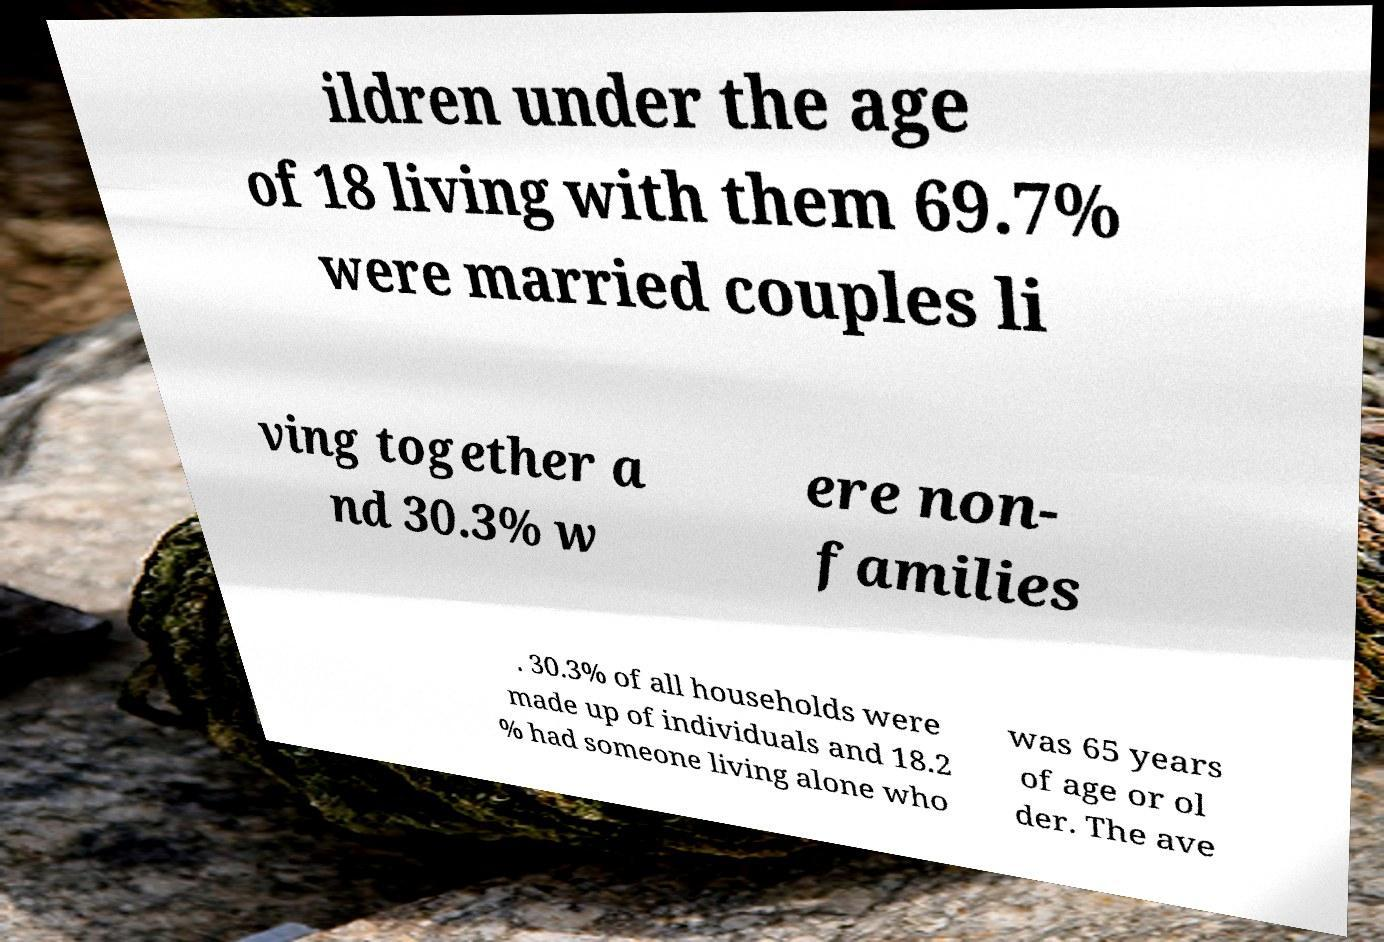Please identify and transcribe the text found in this image. ildren under the age of 18 living with them 69.7% were married couples li ving together a nd 30.3% w ere non- families . 30.3% of all households were made up of individuals and 18.2 % had someone living alone who was 65 years of age or ol der. The ave 